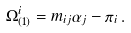<formula> <loc_0><loc_0><loc_500><loc_500>\Omega _ { ( 1 ) } ^ { i } = m _ { i j } \alpha _ { j } - \pi _ { i } \, .</formula> 